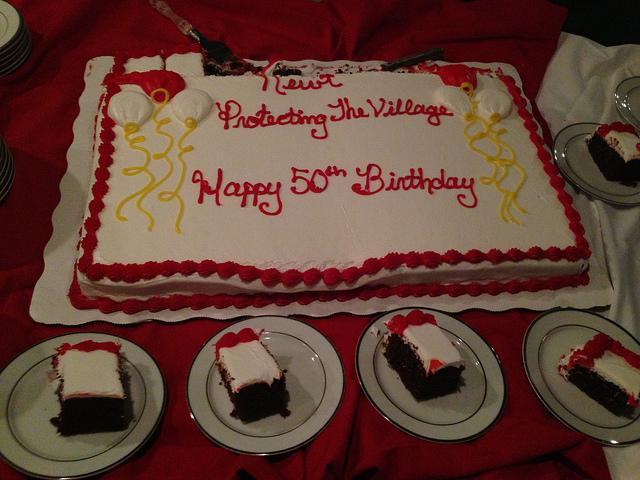How many pieces of cake are on a plate?
Give a very brief answer. 1. How many plates in this stack?
Give a very brief answer. 5. How many cakes are sliced?
Give a very brief answer. 5. How many smalls dishes are there?
Give a very brief answer. 6. How many cut slices of cake are shown?
Give a very brief answer. 5. How many bowls are on the mat?
Give a very brief answer. 0. How many items are shown?
Give a very brief answer. 6. How many cakes can you see?
Give a very brief answer. 6. 